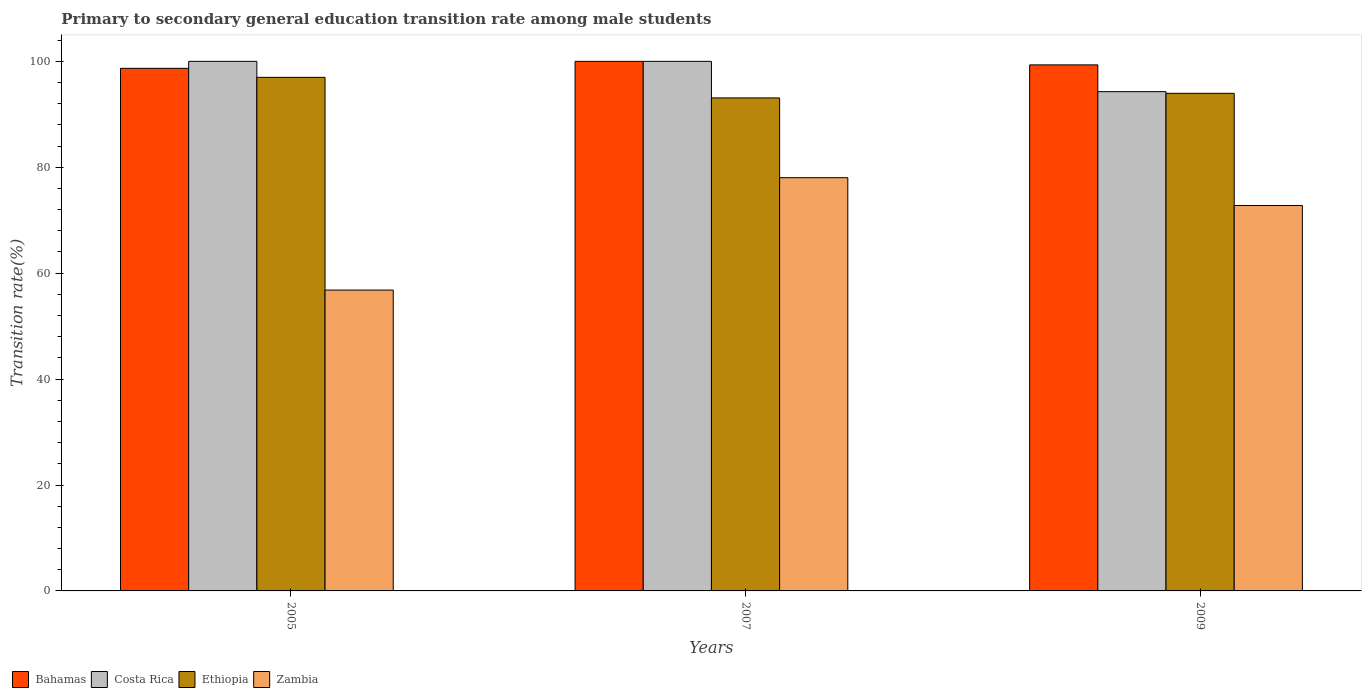How many groups of bars are there?
Your response must be concise. 3. Are the number of bars on each tick of the X-axis equal?
Keep it short and to the point. Yes. What is the transition rate in Ethiopia in 2007?
Provide a short and direct response. 93.1. Across all years, what is the minimum transition rate in Zambia?
Your answer should be very brief. 56.81. In which year was the transition rate in Zambia minimum?
Give a very brief answer. 2005. What is the total transition rate in Zambia in the graph?
Offer a very short reply. 207.62. What is the difference between the transition rate in Costa Rica in 2007 and that in 2009?
Offer a terse response. 5.72. What is the difference between the transition rate in Zambia in 2007 and the transition rate in Bahamas in 2009?
Your answer should be compact. -21.3. What is the average transition rate in Bahamas per year?
Your response must be concise. 99.34. In the year 2005, what is the difference between the transition rate in Costa Rica and transition rate in Ethiopia?
Offer a terse response. 3.02. In how many years, is the transition rate in Bahamas greater than 12 %?
Your answer should be very brief. 3. What is the ratio of the transition rate in Costa Rica in 2005 to that in 2007?
Provide a short and direct response. 1. Is the difference between the transition rate in Costa Rica in 2005 and 2007 greater than the difference between the transition rate in Ethiopia in 2005 and 2007?
Keep it short and to the point. No. What is the difference between the highest and the second highest transition rate in Bahamas?
Provide a succinct answer. 0.67. What is the difference between the highest and the lowest transition rate in Costa Rica?
Keep it short and to the point. 5.72. What does the 1st bar from the left in 2009 represents?
Your response must be concise. Bahamas. What does the 4th bar from the right in 2005 represents?
Your answer should be compact. Bahamas. Is it the case that in every year, the sum of the transition rate in Costa Rica and transition rate in Bahamas is greater than the transition rate in Zambia?
Offer a terse response. Yes. How many years are there in the graph?
Your answer should be very brief. 3. What is the difference between two consecutive major ticks on the Y-axis?
Give a very brief answer. 20. Where does the legend appear in the graph?
Your answer should be very brief. Bottom left. How many legend labels are there?
Your answer should be very brief. 4. How are the legend labels stacked?
Give a very brief answer. Horizontal. What is the title of the graph?
Provide a short and direct response. Primary to secondary general education transition rate among male students. Does "Northern Mariana Islands" appear as one of the legend labels in the graph?
Offer a terse response. No. What is the label or title of the X-axis?
Offer a very short reply. Years. What is the label or title of the Y-axis?
Provide a short and direct response. Transition rate(%). What is the Transition rate(%) in Bahamas in 2005?
Your response must be concise. 98.68. What is the Transition rate(%) of Costa Rica in 2005?
Offer a very short reply. 100. What is the Transition rate(%) in Ethiopia in 2005?
Provide a succinct answer. 96.98. What is the Transition rate(%) of Zambia in 2005?
Make the answer very short. 56.81. What is the Transition rate(%) in Bahamas in 2007?
Keep it short and to the point. 100. What is the Transition rate(%) in Costa Rica in 2007?
Make the answer very short. 100. What is the Transition rate(%) of Ethiopia in 2007?
Your answer should be compact. 93.1. What is the Transition rate(%) in Zambia in 2007?
Keep it short and to the point. 78.03. What is the Transition rate(%) of Bahamas in 2009?
Your response must be concise. 99.33. What is the Transition rate(%) of Costa Rica in 2009?
Keep it short and to the point. 94.28. What is the Transition rate(%) in Ethiopia in 2009?
Offer a very short reply. 93.96. What is the Transition rate(%) in Zambia in 2009?
Offer a terse response. 72.78. Across all years, what is the maximum Transition rate(%) of Costa Rica?
Your response must be concise. 100. Across all years, what is the maximum Transition rate(%) in Ethiopia?
Your answer should be compact. 96.98. Across all years, what is the maximum Transition rate(%) of Zambia?
Your answer should be compact. 78.03. Across all years, what is the minimum Transition rate(%) in Bahamas?
Make the answer very short. 98.68. Across all years, what is the minimum Transition rate(%) in Costa Rica?
Give a very brief answer. 94.28. Across all years, what is the minimum Transition rate(%) of Ethiopia?
Your response must be concise. 93.1. Across all years, what is the minimum Transition rate(%) of Zambia?
Make the answer very short. 56.81. What is the total Transition rate(%) in Bahamas in the graph?
Your response must be concise. 298.01. What is the total Transition rate(%) of Costa Rica in the graph?
Your answer should be very brief. 294.28. What is the total Transition rate(%) in Ethiopia in the graph?
Make the answer very short. 284.04. What is the total Transition rate(%) in Zambia in the graph?
Give a very brief answer. 207.62. What is the difference between the Transition rate(%) of Bahamas in 2005 and that in 2007?
Give a very brief answer. -1.32. What is the difference between the Transition rate(%) of Ethiopia in 2005 and that in 2007?
Provide a short and direct response. 3.88. What is the difference between the Transition rate(%) of Zambia in 2005 and that in 2007?
Keep it short and to the point. -21.22. What is the difference between the Transition rate(%) of Bahamas in 2005 and that in 2009?
Your answer should be compact. -0.65. What is the difference between the Transition rate(%) in Costa Rica in 2005 and that in 2009?
Your answer should be very brief. 5.72. What is the difference between the Transition rate(%) in Ethiopia in 2005 and that in 2009?
Keep it short and to the point. 3.01. What is the difference between the Transition rate(%) in Zambia in 2005 and that in 2009?
Offer a very short reply. -15.97. What is the difference between the Transition rate(%) of Bahamas in 2007 and that in 2009?
Provide a short and direct response. 0.67. What is the difference between the Transition rate(%) of Costa Rica in 2007 and that in 2009?
Make the answer very short. 5.72. What is the difference between the Transition rate(%) in Ethiopia in 2007 and that in 2009?
Ensure brevity in your answer.  -0.87. What is the difference between the Transition rate(%) of Zambia in 2007 and that in 2009?
Offer a terse response. 5.25. What is the difference between the Transition rate(%) in Bahamas in 2005 and the Transition rate(%) in Costa Rica in 2007?
Provide a short and direct response. -1.32. What is the difference between the Transition rate(%) in Bahamas in 2005 and the Transition rate(%) in Ethiopia in 2007?
Provide a short and direct response. 5.59. What is the difference between the Transition rate(%) in Bahamas in 2005 and the Transition rate(%) in Zambia in 2007?
Provide a succinct answer. 20.65. What is the difference between the Transition rate(%) of Costa Rica in 2005 and the Transition rate(%) of Ethiopia in 2007?
Your answer should be compact. 6.9. What is the difference between the Transition rate(%) in Costa Rica in 2005 and the Transition rate(%) in Zambia in 2007?
Offer a terse response. 21.97. What is the difference between the Transition rate(%) in Ethiopia in 2005 and the Transition rate(%) in Zambia in 2007?
Make the answer very short. 18.95. What is the difference between the Transition rate(%) of Bahamas in 2005 and the Transition rate(%) of Costa Rica in 2009?
Your response must be concise. 4.4. What is the difference between the Transition rate(%) in Bahamas in 2005 and the Transition rate(%) in Ethiopia in 2009?
Provide a short and direct response. 4.72. What is the difference between the Transition rate(%) in Bahamas in 2005 and the Transition rate(%) in Zambia in 2009?
Make the answer very short. 25.9. What is the difference between the Transition rate(%) in Costa Rica in 2005 and the Transition rate(%) in Ethiopia in 2009?
Keep it short and to the point. 6.04. What is the difference between the Transition rate(%) in Costa Rica in 2005 and the Transition rate(%) in Zambia in 2009?
Keep it short and to the point. 27.22. What is the difference between the Transition rate(%) in Ethiopia in 2005 and the Transition rate(%) in Zambia in 2009?
Offer a very short reply. 24.2. What is the difference between the Transition rate(%) of Bahamas in 2007 and the Transition rate(%) of Costa Rica in 2009?
Provide a short and direct response. 5.72. What is the difference between the Transition rate(%) of Bahamas in 2007 and the Transition rate(%) of Ethiopia in 2009?
Ensure brevity in your answer.  6.04. What is the difference between the Transition rate(%) of Bahamas in 2007 and the Transition rate(%) of Zambia in 2009?
Provide a short and direct response. 27.22. What is the difference between the Transition rate(%) in Costa Rica in 2007 and the Transition rate(%) in Ethiopia in 2009?
Your answer should be compact. 6.04. What is the difference between the Transition rate(%) of Costa Rica in 2007 and the Transition rate(%) of Zambia in 2009?
Offer a very short reply. 27.22. What is the difference between the Transition rate(%) in Ethiopia in 2007 and the Transition rate(%) in Zambia in 2009?
Provide a short and direct response. 20.32. What is the average Transition rate(%) in Bahamas per year?
Keep it short and to the point. 99.34. What is the average Transition rate(%) in Costa Rica per year?
Keep it short and to the point. 98.09. What is the average Transition rate(%) of Ethiopia per year?
Ensure brevity in your answer.  94.68. What is the average Transition rate(%) in Zambia per year?
Offer a terse response. 69.21. In the year 2005, what is the difference between the Transition rate(%) of Bahamas and Transition rate(%) of Costa Rica?
Your response must be concise. -1.32. In the year 2005, what is the difference between the Transition rate(%) of Bahamas and Transition rate(%) of Ethiopia?
Your answer should be very brief. 1.7. In the year 2005, what is the difference between the Transition rate(%) in Bahamas and Transition rate(%) in Zambia?
Give a very brief answer. 41.87. In the year 2005, what is the difference between the Transition rate(%) in Costa Rica and Transition rate(%) in Ethiopia?
Provide a succinct answer. 3.02. In the year 2005, what is the difference between the Transition rate(%) in Costa Rica and Transition rate(%) in Zambia?
Offer a very short reply. 43.19. In the year 2005, what is the difference between the Transition rate(%) in Ethiopia and Transition rate(%) in Zambia?
Give a very brief answer. 40.17. In the year 2007, what is the difference between the Transition rate(%) in Bahamas and Transition rate(%) in Ethiopia?
Your answer should be compact. 6.9. In the year 2007, what is the difference between the Transition rate(%) of Bahamas and Transition rate(%) of Zambia?
Provide a short and direct response. 21.97. In the year 2007, what is the difference between the Transition rate(%) in Costa Rica and Transition rate(%) in Ethiopia?
Make the answer very short. 6.9. In the year 2007, what is the difference between the Transition rate(%) of Costa Rica and Transition rate(%) of Zambia?
Your response must be concise. 21.97. In the year 2007, what is the difference between the Transition rate(%) of Ethiopia and Transition rate(%) of Zambia?
Give a very brief answer. 15.07. In the year 2009, what is the difference between the Transition rate(%) of Bahamas and Transition rate(%) of Costa Rica?
Provide a short and direct response. 5.05. In the year 2009, what is the difference between the Transition rate(%) in Bahamas and Transition rate(%) in Ethiopia?
Give a very brief answer. 5.37. In the year 2009, what is the difference between the Transition rate(%) of Bahamas and Transition rate(%) of Zambia?
Your response must be concise. 26.55. In the year 2009, what is the difference between the Transition rate(%) in Costa Rica and Transition rate(%) in Ethiopia?
Offer a terse response. 0.31. In the year 2009, what is the difference between the Transition rate(%) in Costa Rica and Transition rate(%) in Zambia?
Offer a terse response. 21.5. In the year 2009, what is the difference between the Transition rate(%) of Ethiopia and Transition rate(%) of Zambia?
Your response must be concise. 21.18. What is the ratio of the Transition rate(%) in Bahamas in 2005 to that in 2007?
Make the answer very short. 0.99. What is the ratio of the Transition rate(%) in Costa Rica in 2005 to that in 2007?
Offer a terse response. 1. What is the ratio of the Transition rate(%) in Ethiopia in 2005 to that in 2007?
Your answer should be very brief. 1.04. What is the ratio of the Transition rate(%) of Zambia in 2005 to that in 2007?
Offer a terse response. 0.73. What is the ratio of the Transition rate(%) in Bahamas in 2005 to that in 2009?
Provide a short and direct response. 0.99. What is the ratio of the Transition rate(%) of Costa Rica in 2005 to that in 2009?
Offer a terse response. 1.06. What is the ratio of the Transition rate(%) in Ethiopia in 2005 to that in 2009?
Ensure brevity in your answer.  1.03. What is the ratio of the Transition rate(%) of Zambia in 2005 to that in 2009?
Provide a short and direct response. 0.78. What is the ratio of the Transition rate(%) of Costa Rica in 2007 to that in 2009?
Make the answer very short. 1.06. What is the ratio of the Transition rate(%) of Ethiopia in 2007 to that in 2009?
Ensure brevity in your answer.  0.99. What is the ratio of the Transition rate(%) in Zambia in 2007 to that in 2009?
Offer a very short reply. 1.07. What is the difference between the highest and the second highest Transition rate(%) in Bahamas?
Provide a short and direct response. 0.67. What is the difference between the highest and the second highest Transition rate(%) of Ethiopia?
Ensure brevity in your answer.  3.01. What is the difference between the highest and the second highest Transition rate(%) in Zambia?
Your answer should be very brief. 5.25. What is the difference between the highest and the lowest Transition rate(%) in Bahamas?
Offer a very short reply. 1.32. What is the difference between the highest and the lowest Transition rate(%) in Costa Rica?
Your answer should be compact. 5.72. What is the difference between the highest and the lowest Transition rate(%) in Ethiopia?
Offer a terse response. 3.88. What is the difference between the highest and the lowest Transition rate(%) of Zambia?
Offer a very short reply. 21.22. 